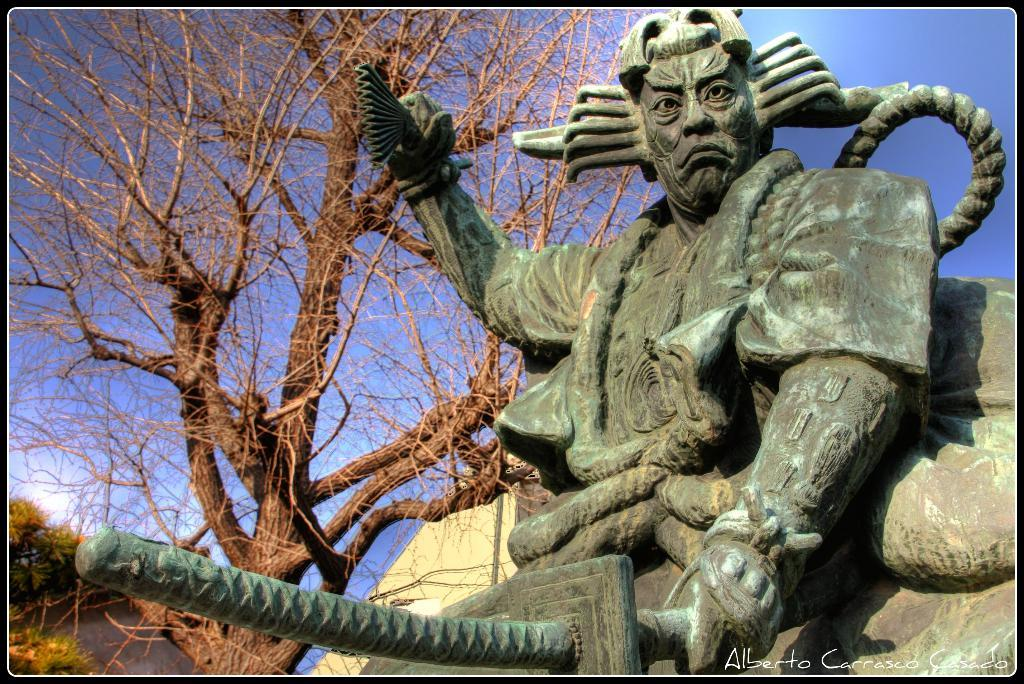What can be seen at the top of the image? The sky is visible towards the top of the image. What type of natural elements are present in the image? There are trees in the image. What is the main subject of the image? There is a sculpture of a man in the image. What is the man holding in the image? The man is holding a sword. What can be found towards the bottom of the image? There is text towards the bottom of the image. How does the guide help the man smash the country in the image? There is no guide or country present in the image; it features a sculpture of a man holding a sword. What type of country is depicted in the image? There is no country depicted in the image; it features a sculpture of a man holding a sword. 